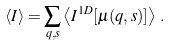Convert formula to latex. <formula><loc_0><loc_0><loc_500><loc_500>\left < I \right > = \sum _ { q , s } \left < I ^ { 1 D } [ \mu ( q , s ) ] \right > \, .</formula> 